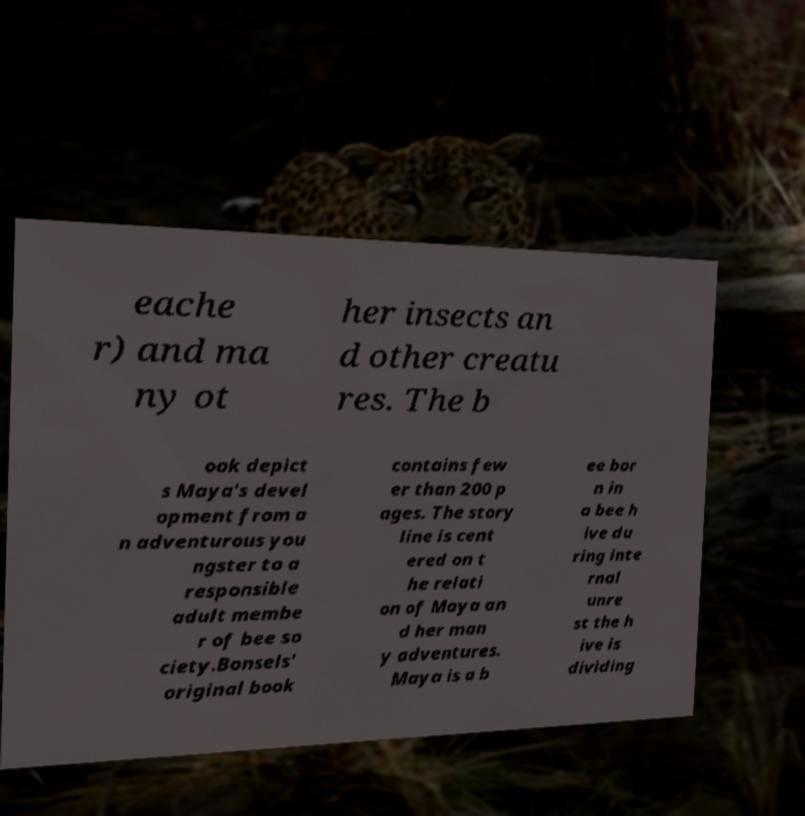For documentation purposes, I need the text within this image transcribed. Could you provide that? eache r) and ma ny ot her insects an d other creatu res. The b ook depict s Maya's devel opment from a n adventurous you ngster to a responsible adult membe r of bee so ciety.Bonsels' original book contains few er than 200 p ages. The story line is cent ered on t he relati on of Maya an d her man y adventures. Maya is a b ee bor n in a bee h ive du ring inte rnal unre st the h ive is dividing 